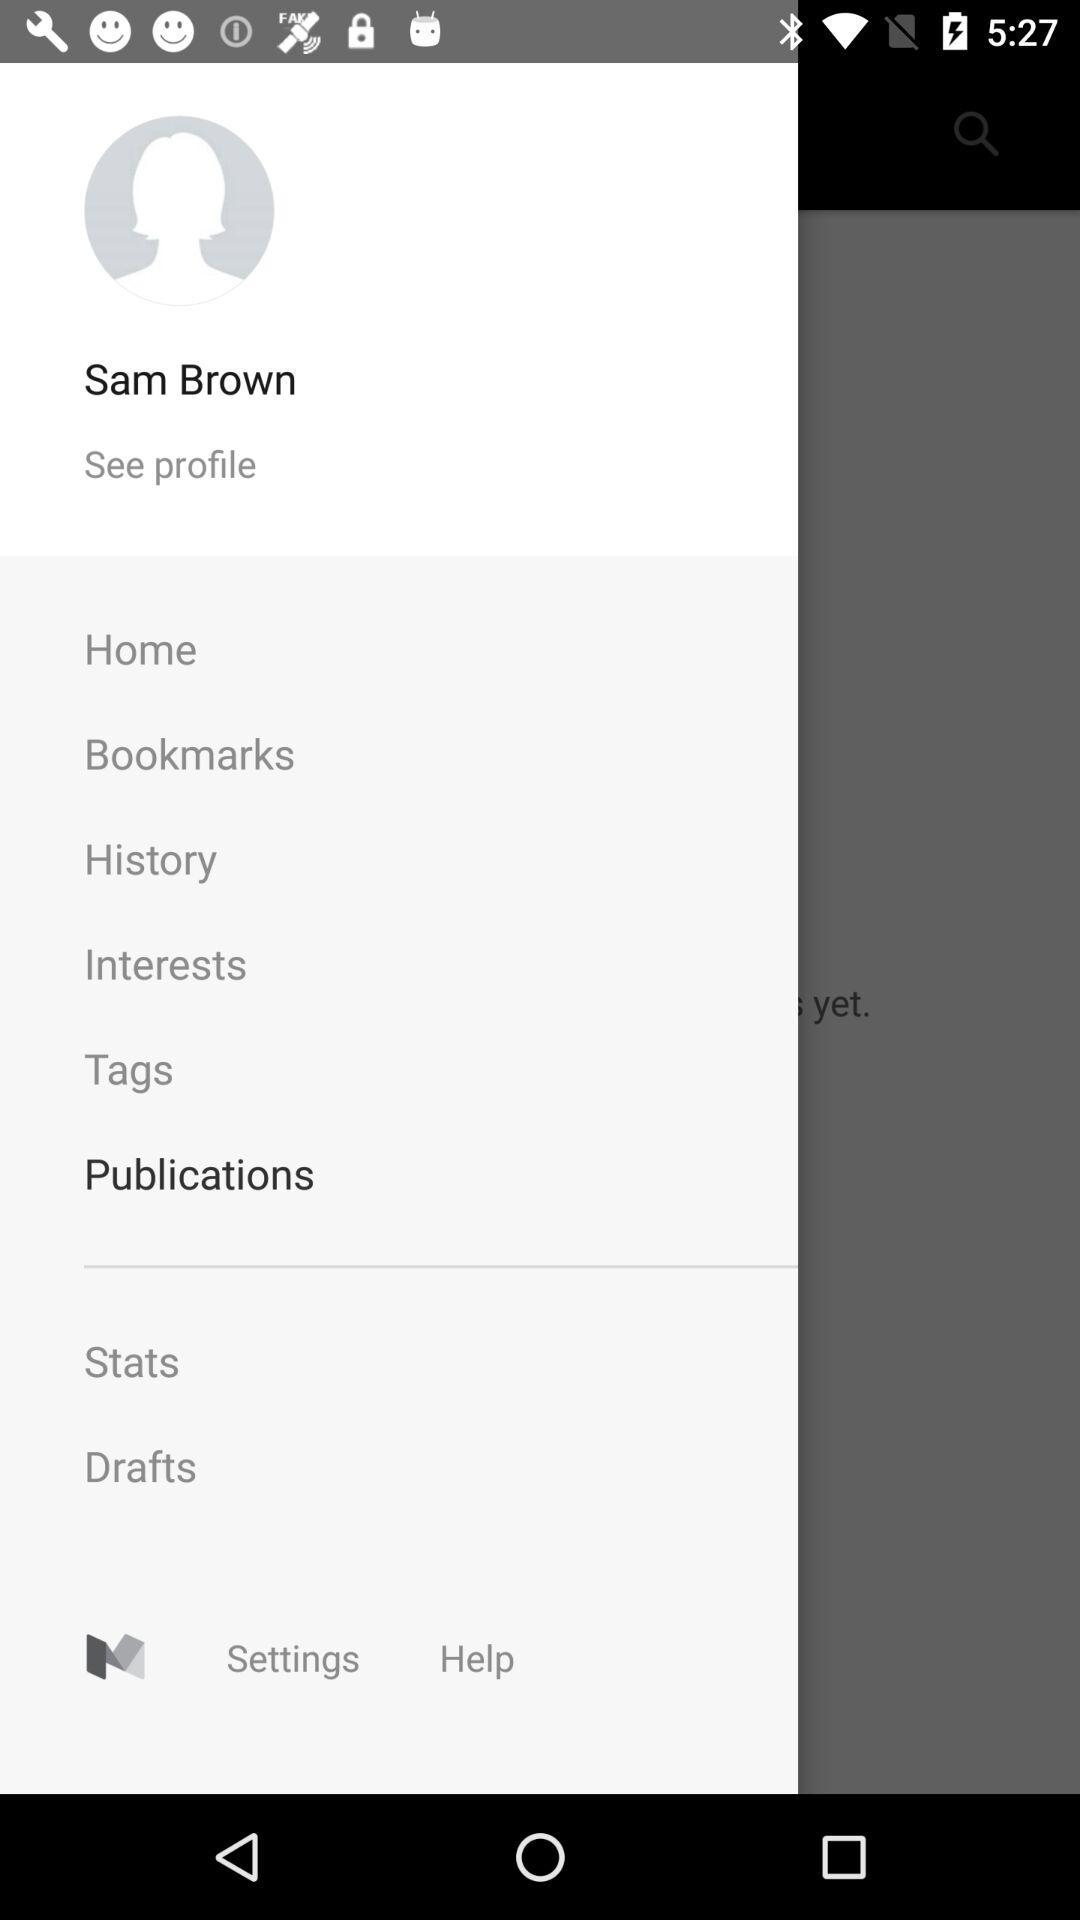What are the bookmarks?
When the provided information is insufficient, respond with <no answer>. <no answer> 